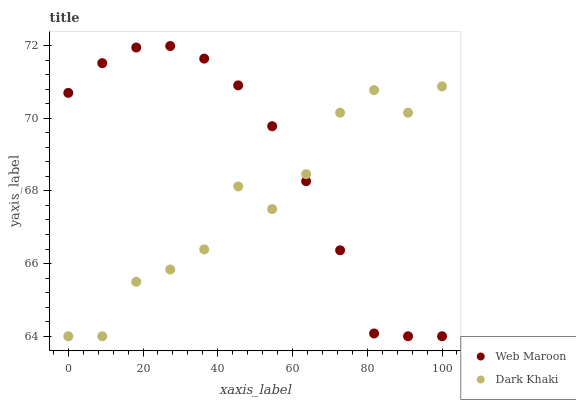Does Dark Khaki have the minimum area under the curve?
Answer yes or no. Yes. Does Web Maroon have the maximum area under the curve?
Answer yes or no. Yes. Does Web Maroon have the minimum area under the curve?
Answer yes or no. No. Is Web Maroon the smoothest?
Answer yes or no. Yes. Is Dark Khaki the roughest?
Answer yes or no. Yes. Is Web Maroon the roughest?
Answer yes or no. No. Does Dark Khaki have the lowest value?
Answer yes or no. Yes. Does Web Maroon have the highest value?
Answer yes or no. Yes. Does Dark Khaki intersect Web Maroon?
Answer yes or no. Yes. Is Dark Khaki less than Web Maroon?
Answer yes or no. No. Is Dark Khaki greater than Web Maroon?
Answer yes or no. No. 